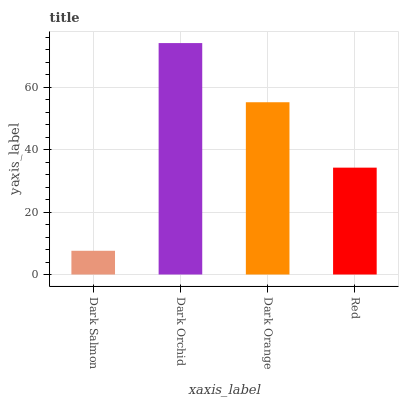Is Dark Salmon the minimum?
Answer yes or no. Yes. Is Dark Orchid the maximum?
Answer yes or no. Yes. Is Dark Orange the minimum?
Answer yes or no. No. Is Dark Orange the maximum?
Answer yes or no. No. Is Dark Orchid greater than Dark Orange?
Answer yes or no. Yes. Is Dark Orange less than Dark Orchid?
Answer yes or no. Yes. Is Dark Orange greater than Dark Orchid?
Answer yes or no. No. Is Dark Orchid less than Dark Orange?
Answer yes or no. No. Is Dark Orange the high median?
Answer yes or no. Yes. Is Red the low median?
Answer yes or no. Yes. Is Dark Salmon the high median?
Answer yes or no. No. Is Dark Orange the low median?
Answer yes or no. No. 